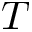<formula> <loc_0><loc_0><loc_500><loc_500>T</formula> 